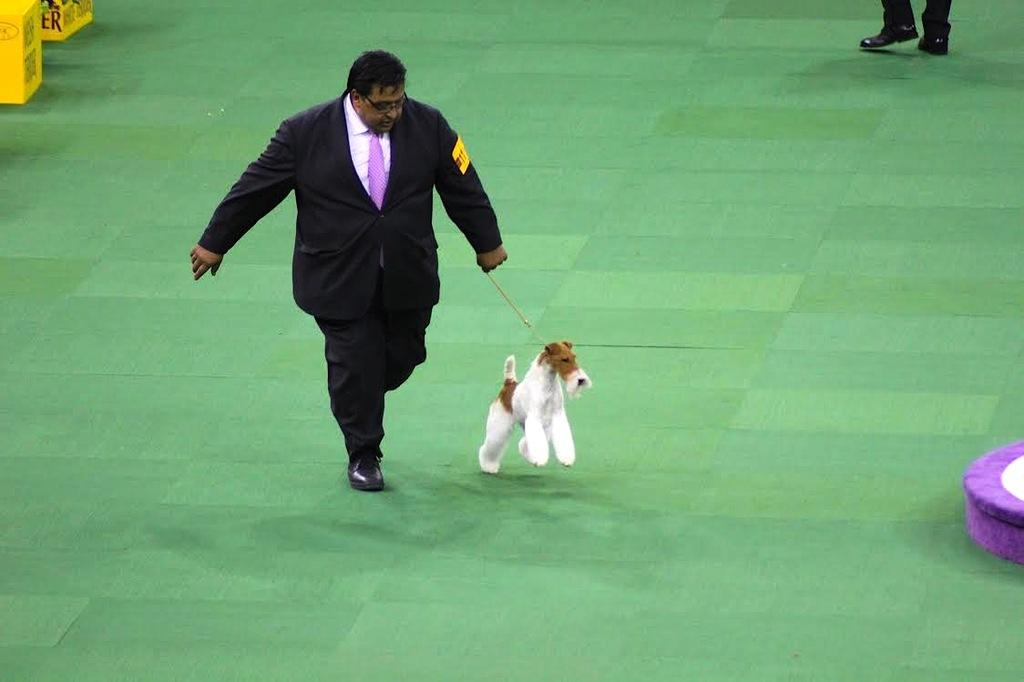Who is present in the image? There is a man in the image. What is the man holding in the image? The man is holding a dog belt in the image. What is the man doing in the image? The man is walking in the image. What can be seen in the background of the image? There is a board visible in the background of the image. What type of train can be seen in the image? There is no train present in the image; it features a man walking with a dog belt. How does the man's death contribute to the scene in the image? There is no mention of the man's death in the image, and he is shown walking, so it cannot be related to the scene. 